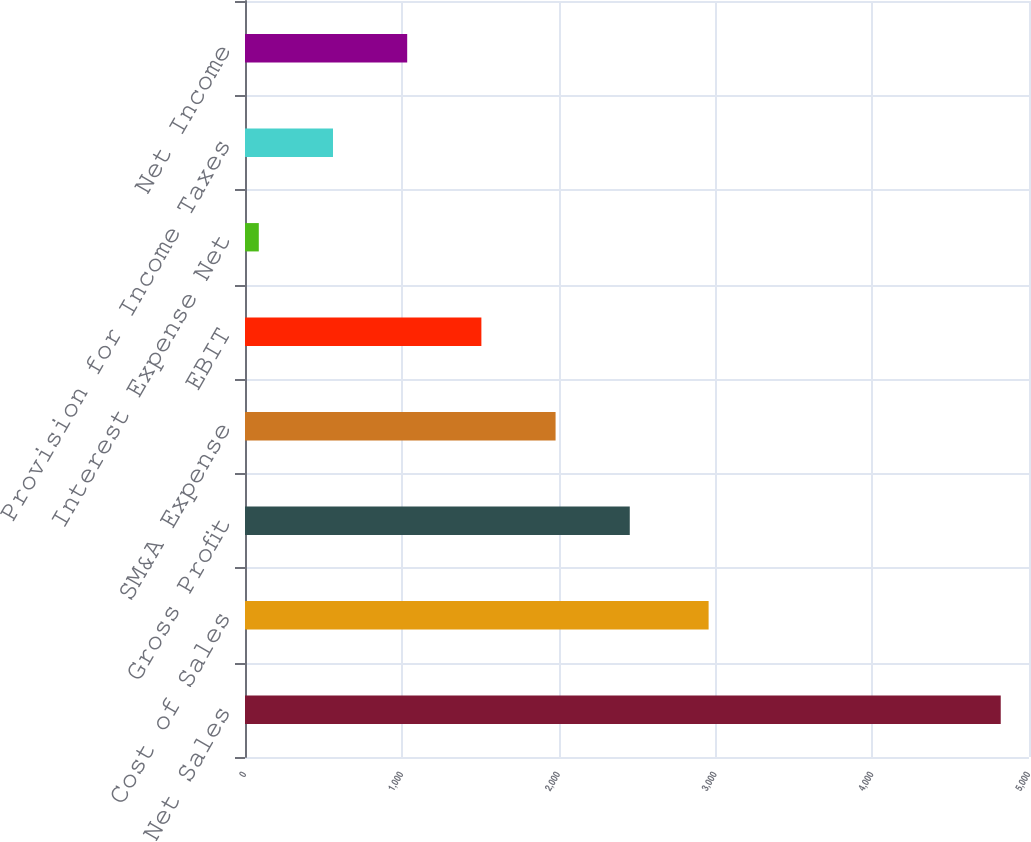Convert chart. <chart><loc_0><loc_0><loc_500><loc_500><bar_chart><fcel>Net Sales<fcel>Cost of Sales<fcel>Gross Profit<fcel>SM&A Expense<fcel>EBIT<fcel>Interest Expense Net<fcel>Provision for Income Taxes<fcel>Net Income<nl><fcel>4819.8<fcel>2956.7<fcel>2453.9<fcel>1980.72<fcel>1507.54<fcel>88<fcel>561.18<fcel>1034.36<nl></chart> 